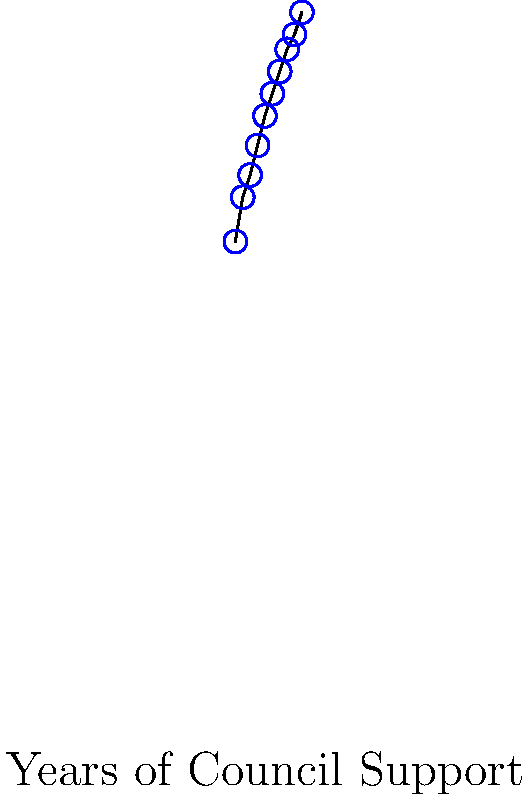Based on the scatter plot showing the correlation between years of council support and business success rates, what is the approximate increase in business success rate for each additional year of council support? To determine the approximate increase in business success rate for each additional year of council support, we need to follow these steps:

1. Identify the overall trend: The scatter plot shows a clear positive correlation between years of council support and business success rates.

2. Estimate the total change:
   - Initial success rate (Year 1): approximately 62%
   - Final success rate (Year 10): approximately 93%
   - Total change: 93% - 62% = 31%

3. Calculate the change per year:
   - Total years of support: 10 years
   - Average change per year: 31% / 10 years = 3.1%

4. Verify with the trend line:
   - The red trend line confirms a steady increase over the 10-year period
   - The slope of the trend line is consistent with our calculation

5. Round for approximation:
   Given the nature of the data and the question asking for an approximate value, we can round 3.1% to 3%.

Therefore, the approximate increase in business success rate for each additional year of council support is 3%.
Answer: 3% per year 